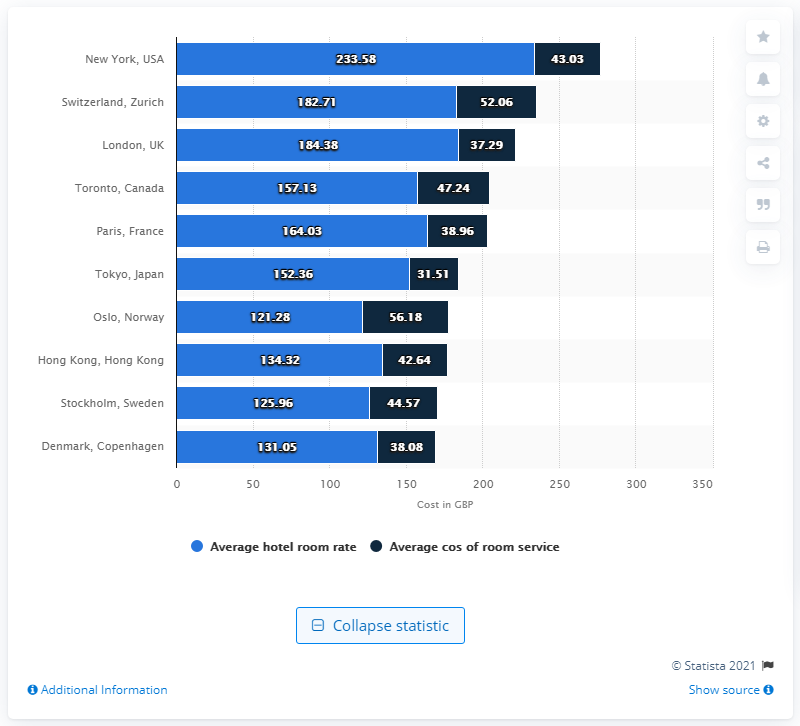Give some essential details in this illustration. The city with the most expensive hotel room for international travelers in 2015 was New York, USA. 